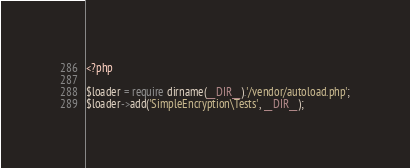Convert code to text. <code><loc_0><loc_0><loc_500><loc_500><_PHP_><?php

$loader = require dirname(__DIR__).'/vendor/autoload.php';
$loader->add('SimpleEncryption\Tests', __DIR__);
</code> 